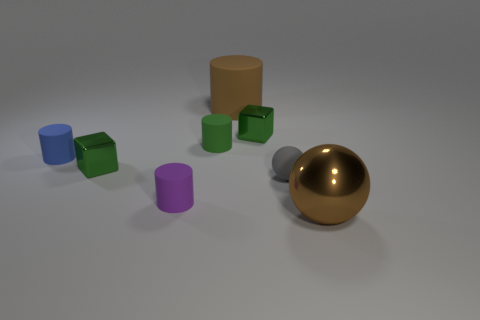There is a green metallic object that is behind the blue cylinder; is it the same shape as the large object in front of the tiny ball?
Provide a succinct answer. No. What is the size of the cube behind the tiny shiny cube left of the big brown matte cylinder to the right of the small blue matte cylinder?
Offer a very short reply. Small. How big is the metal block in front of the small blue thing?
Your answer should be very brief. Small. What material is the brown object behind the small purple thing?
Keep it short and to the point. Rubber. How many yellow objects are either rubber objects or big cylinders?
Your answer should be compact. 0. Does the tiny ball have the same material as the green block left of the big brown rubber thing?
Give a very brief answer. No. Are there the same number of tiny green objects in front of the brown metal thing and big brown things that are on the left side of the tiny gray sphere?
Provide a succinct answer. No. There is a green cylinder; is it the same size as the matte object that is in front of the gray thing?
Your answer should be very brief. Yes. Is the number of brown things that are behind the big brown sphere greater than the number of large red blocks?
Provide a succinct answer. Yes. What number of purple rubber cylinders are the same size as the gray rubber object?
Give a very brief answer. 1. 